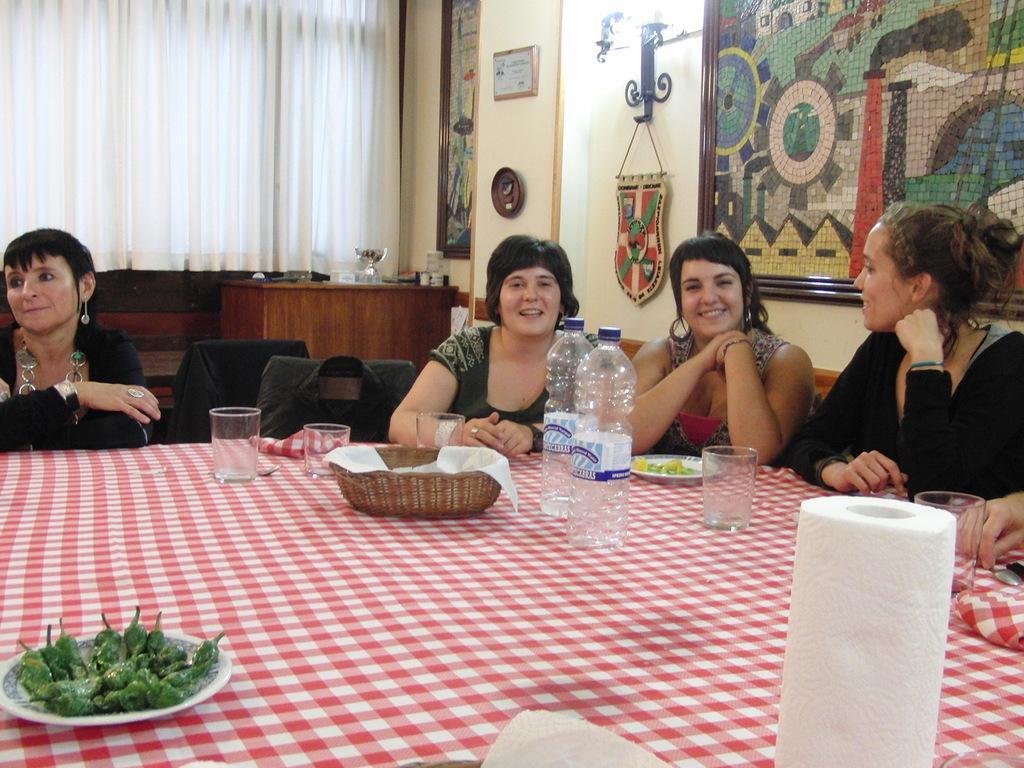Could you give a brief overview of what you see in this image? This is the picture of the inside of the restaurant. They all are sitting in a chair. Everyone is laughing. There is a table. There is a bowl,water bottles,vegetables,glass and tissues on a table. We can see in the background there is a name poster,cupboard,photo gallery. 